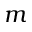Convert formula to latex. <formula><loc_0><loc_0><loc_500><loc_500>m</formula> 